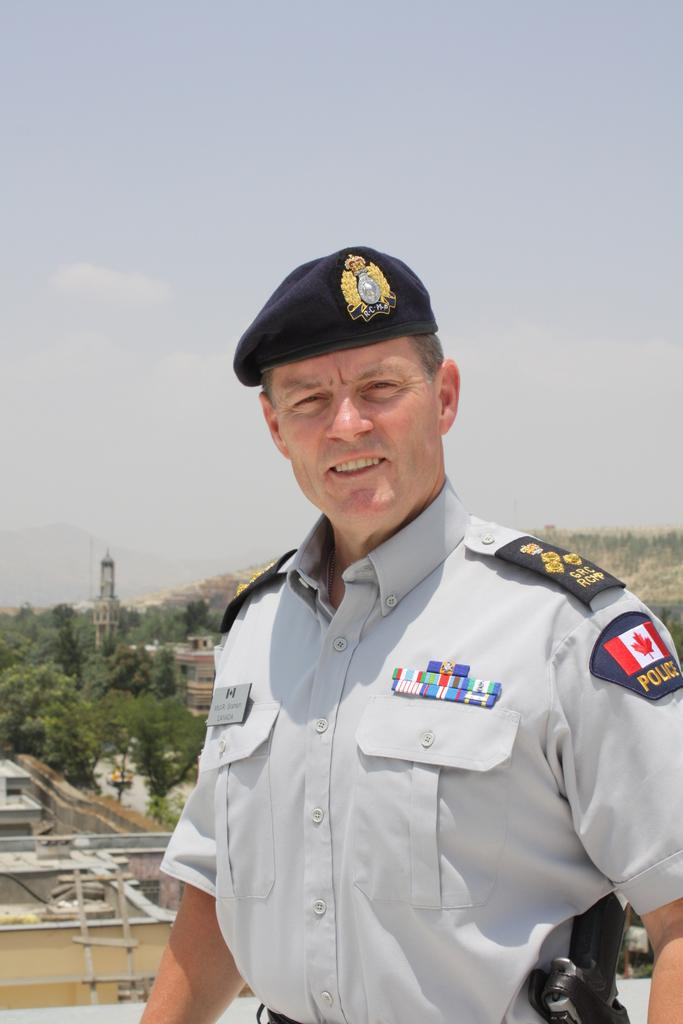Who is present in the image? There is a man in the image. What can be seen in the background of the image? There are buildings, trees, hills, and the sky visible in the background of the image. What type of fish can be seen swimming in the sky in the image? There are no fish present in the image, and the sky is not depicted as a body of water where fish could swim. 